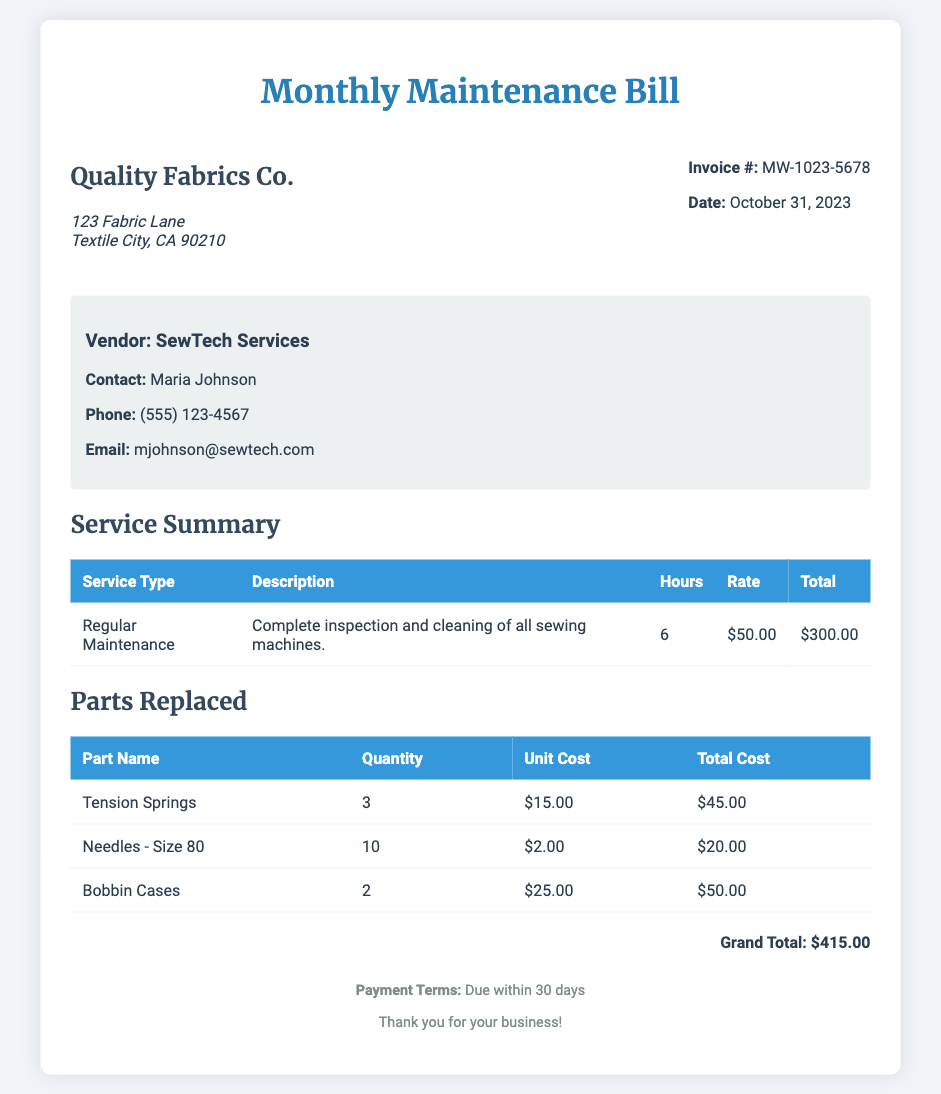What is the invoice number? The invoice number is specified in the document as a unique identifier for this transaction.
Answer: MW-1023-5678 What is the date of the bill? The date is mentioned in the document and indicates when the bill was issued.
Answer: October 31, 2023 Who is the contact person for the vendor? The contact person is listed in the vendor information section of the document.
Answer: Maria Johnson What is the total number of Tension Springs replaced? The document specifies the quantity of each part replaced.
Answer: 3 What was the charge for Regular Maintenance? The total cost for Regular Maintenance is calculated in the service summary section.
Answer: $300.00 What is the Grand Total for the maintenance bill? The Grand Total is the sum indicated at the end of the document.
Answer: $415.00 How many hours were spent on Regular Maintenance? The number of hours spent is mentioned in the service summary section.
Answer: 6 What is the unit cost of Needles - Size 80? The unit cost for each part is specified in the parts replaced table.
Answer: $2.00 What is the payment term for this bill? The payment terms are specified in the footer of the document.
Answer: Due within 30 days 